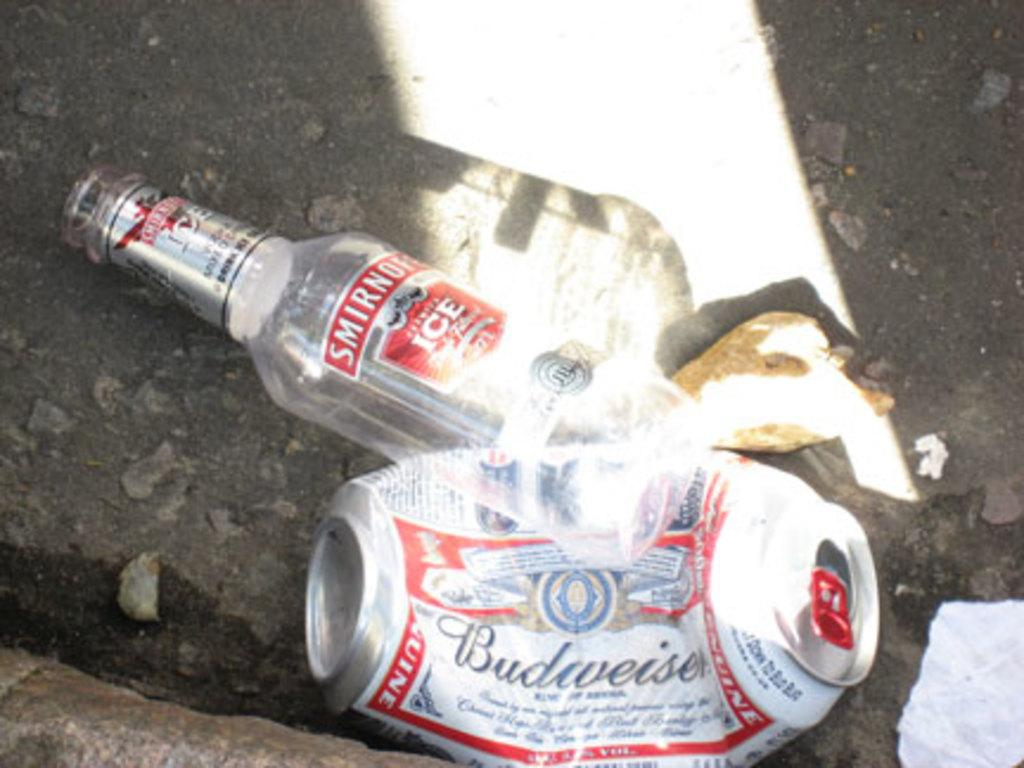<image>
Offer a succinct explanation of the picture presented. An empty crumpled budweiser beer can lies in the street next to a empty Smirnoff vodka bottle. 